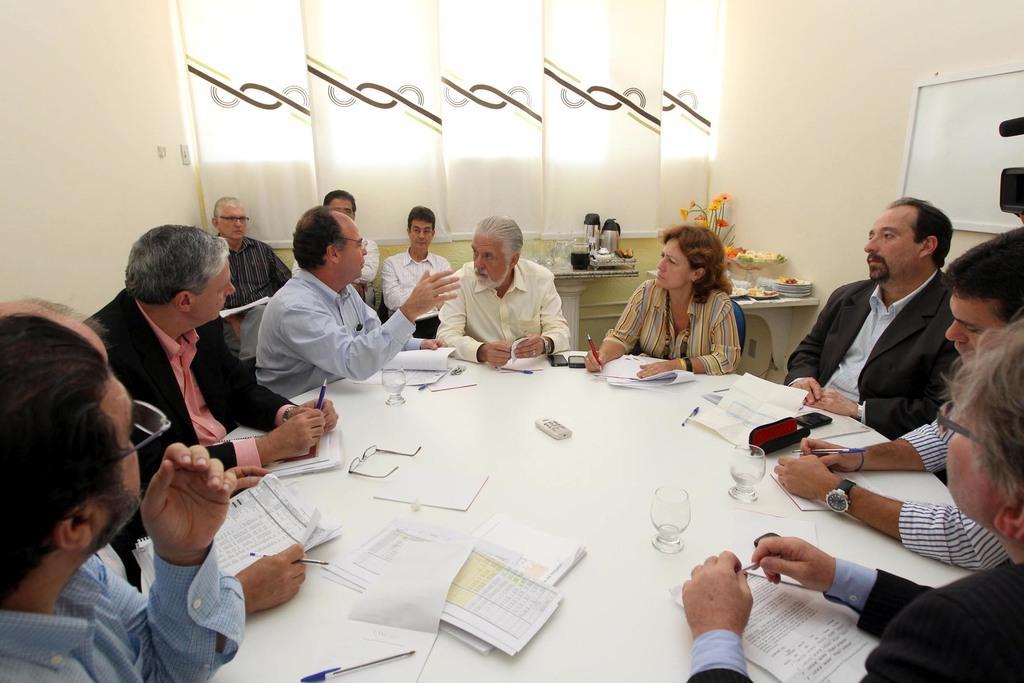Could you give a brief overview of what you see in this image? In this image I see number of people who are sitting on chairs and there is a table over here on which there are lot of papers, glasses, pens and a spectacle over here. In the background I see the wall, a board, curtain and few things on the tables. 